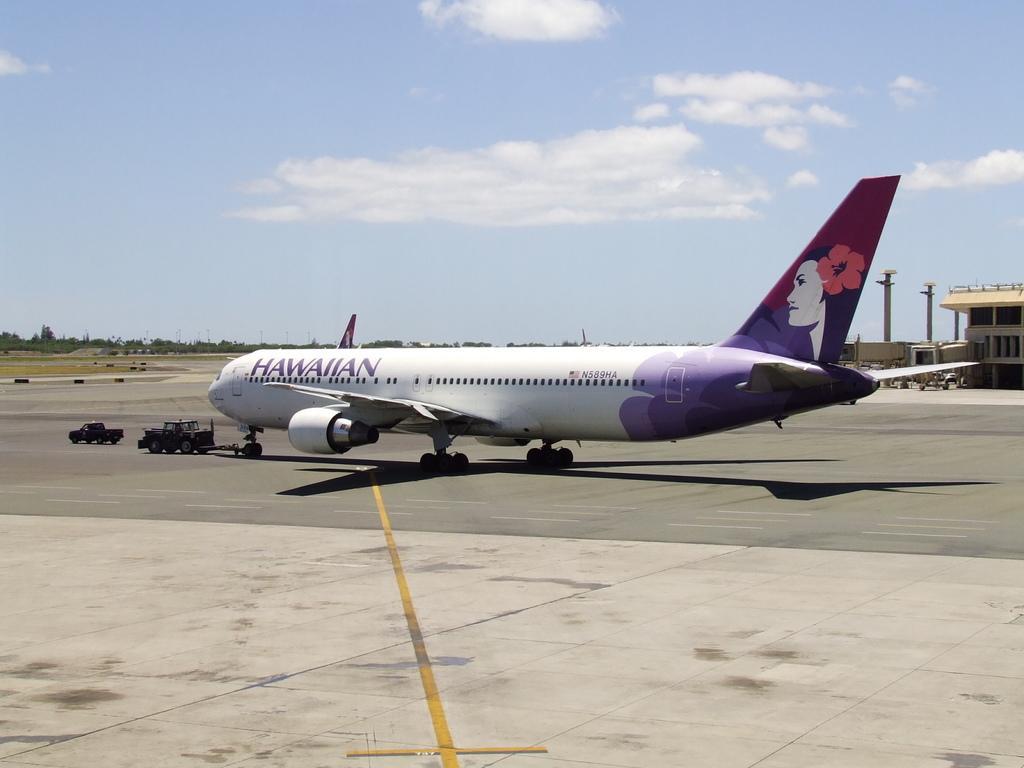Could you give a brief overview of what you see in this image? This picture is clicked outside. In the center we can see an airplane seems to be parked on the ground and we can see the vehicles, buildings, trees, sky, clouds and many other objects and we can see the text and some picture on the airplane. 